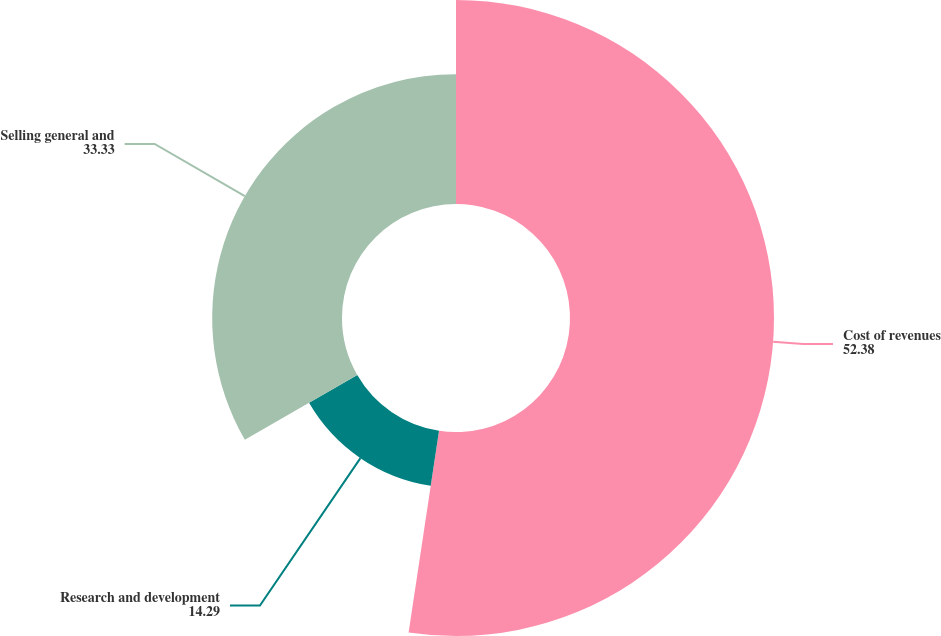Convert chart. <chart><loc_0><loc_0><loc_500><loc_500><pie_chart><fcel>Cost of revenues<fcel>Research and development<fcel>Selling general and<nl><fcel>52.38%<fcel>14.29%<fcel>33.33%<nl></chart> 